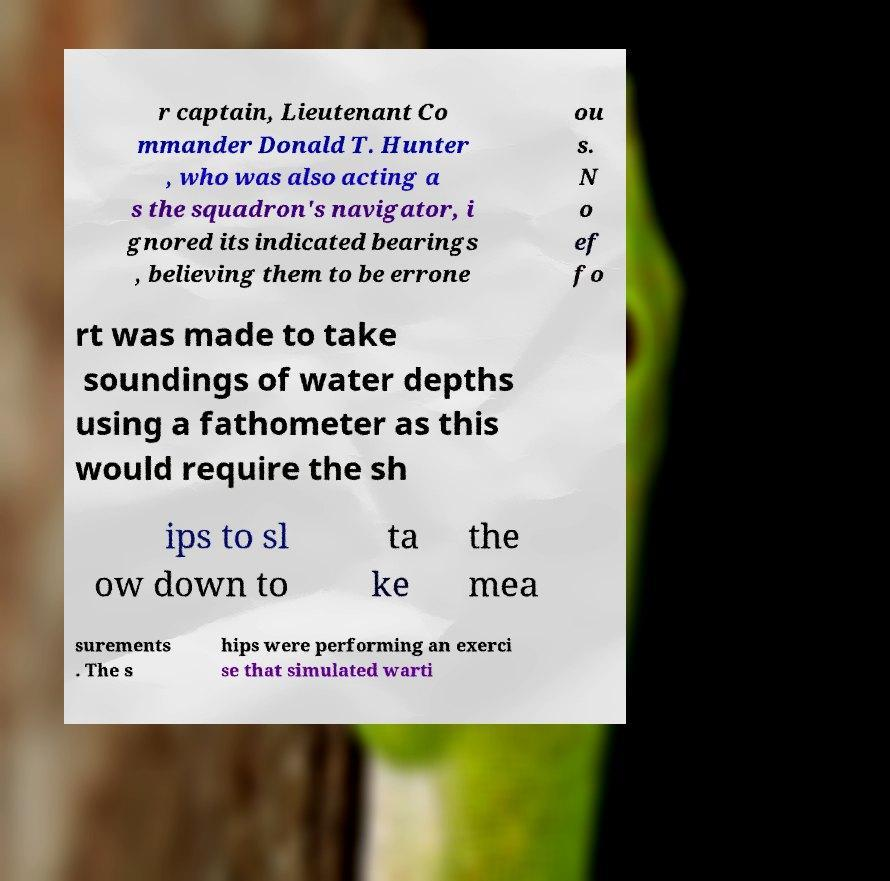Can you read and provide the text displayed in the image?This photo seems to have some interesting text. Can you extract and type it out for me? r captain, Lieutenant Co mmander Donald T. Hunter , who was also acting a s the squadron's navigator, i gnored its indicated bearings , believing them to be errone ou s. N o ef fo rt was made to take soundings of water depths using a fathometer as this would require the sh ips to sl ow down to ta ke the mea surements . The s hips were performing an exerci se that simulated warti 